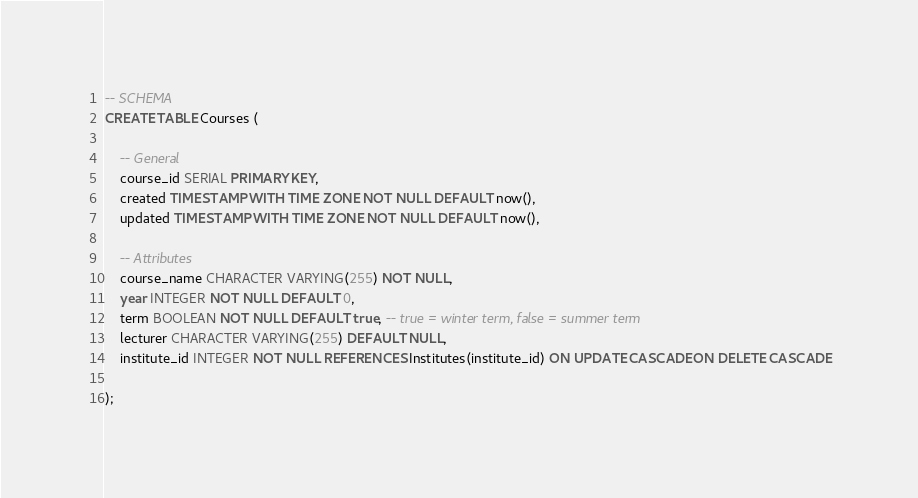Convert code to text. <code><loc_0><loc_0><loc_500><loc_500><_SQL_>
-- SCHEMA
CREATE TABLE Courses (

    -- General
    course_id SERIAL PRIMARY KEY,
    created TIMESTAMP WITH TIME ZONE NOT NULL DEFAULT now(),
    updated TIMESTAMP WITH TIME ZONE NOT NULL DEFAULT now(),

    -- Attributes
    course_name CHARACTER VARYING(255) NOT NULL,
    year INTEGER NOT NULL DEFAULT 0,
    term BOOLEAN NOT NULL DEFAULT true, -- true = winter term, false = summer term
    lecturer CHARACTER VARYING(255) DEFAULT NULL,
    institute_id INTEGER NOT NULL REFERENCES Institutes(institute_id) ON UPDATE CASCADE ON DELETE CASCADE

);
</code> 